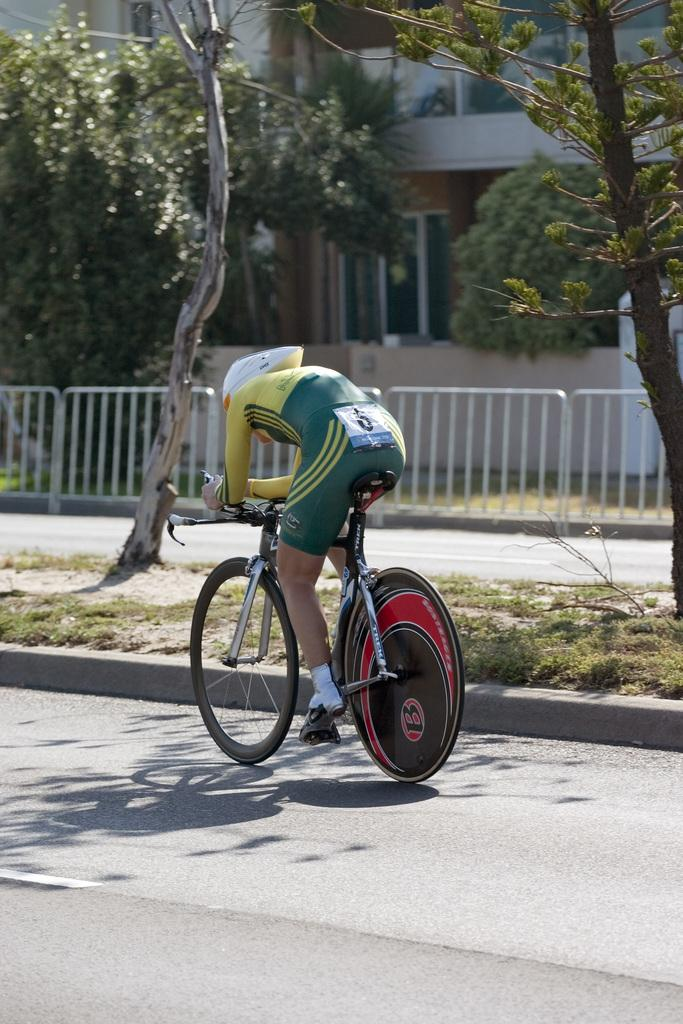What is the main subject of the image? There is a person riding a bicycle in the image. What can be seen in the background of the image? There are trees, fencing, at least one building, and windows visible in the background of the image. What is the title of the team that is participating in the mountain climbing event in the image? There is no team, mountain, or climbing event present in the image; it features a person riding a bicycle with a background of trees, fencing, buildings, and windows. 